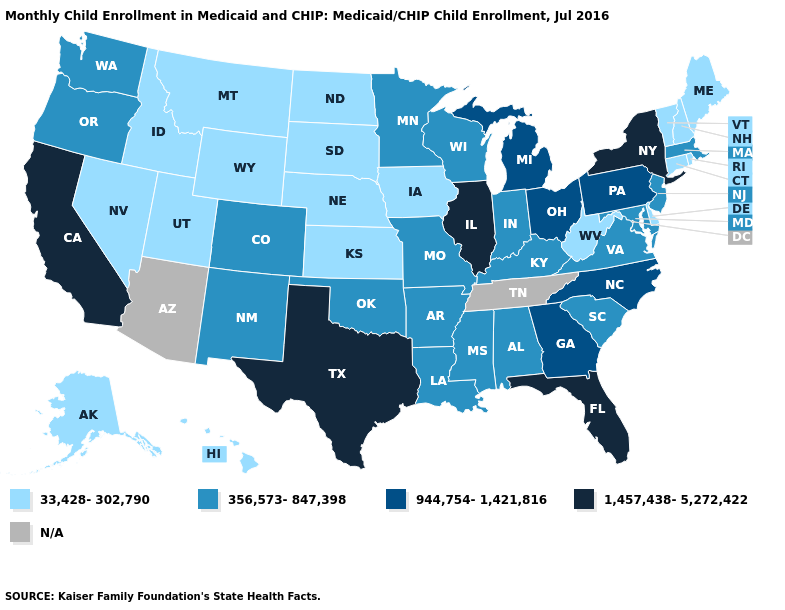Name the states that have a value in the range 1,457,438-5,272,422?
Short answer required. California, Florida, Illinois, New York, Texas. Which states have the lowest value in the MidWest?
Concise answer only. Iowa, Kansas, Nebraska, North Dakota, South Dakota. Among the states that border North Carolina , which have the highest value?
Write a very short answer. Georgia. Name the states that have a value in the range 33,428-302,790?
Answer briefly. Alaska, Connecticut, Delaware, Hawaii, Idaho, Iowa, Kansas, Maine, Montana, Nebraska, Nevada, New Hampshire, North Dakota, Rhode Island, South Dakota, Utah, Vermont, West Virginia, Wyoming. What is the lowest value in the South?
Concise answer only. 33,428-302,790. Among the states that border Virginia , which have the highest value?
Concise answer only. North Carolina. What is the value of Connecticut?
Keep it brief. 33,428-302,790. What is the highest value in states that border Florida?
Be succinct. 944,754-1,421,816. Name the states that have a value in the range 33,428-302,790?
Write a very short answer. Alaska, Connecticut, Delaware, Hawaii, Idaho, Iowa, Kansas, Maine, Montana, Nebraska, Nevada, New Hampshire, North Dakota, Rhode Island, South Dakota, Utah, Vermont, West Virginia, Wyoming. Among the states that border Washington , does Idaho have the lowest value?
Keep it brief. Yes. Among the states that border Montana , which have the lowest value?
Concise answer only. Idaho, North Dakota, South Dakota, Wyoming. Does California have the highest value in the USA?
Keep it brief. Yes. What is the value of Connecticut?
Answer briefly. 33,428-302,790. Name the states that have a value in the range 33,428-302,790?
Give a very brief answer. Alaska, Connecticut, Delaware, Hawaii, Idaho, Iowa, Kansas, Maine, Montana, Nebraska, Nevada, New Hampshire, North Dakota, Rhode Island, South Dakota, Utah, Vermont, West Virginia, Wyoming. 